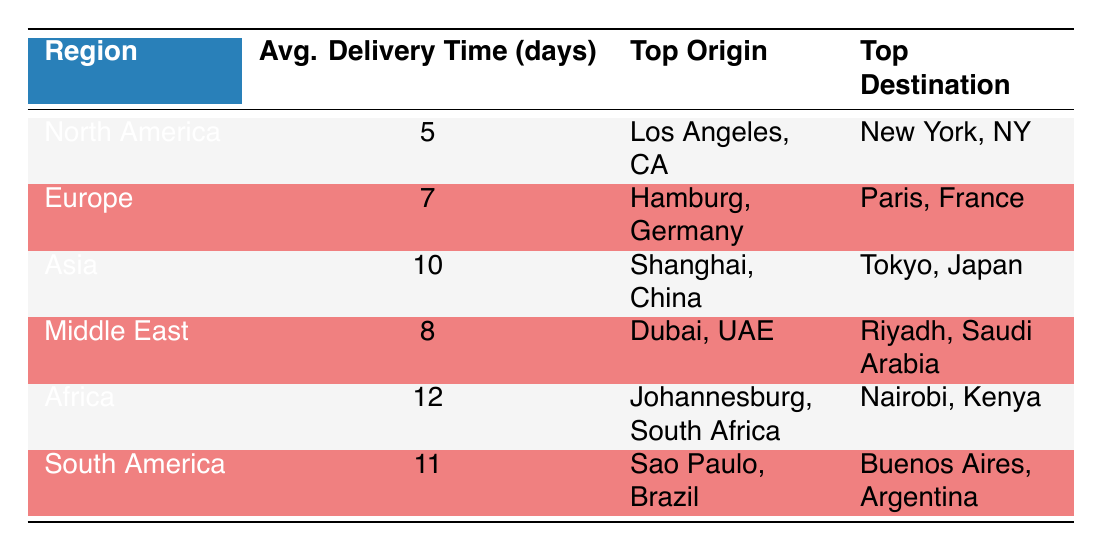What is the average delivery time for goods in North America? The table lists the average delivery time for North America as 5 days.
Answer: 5 days Which region has the longest average delivery time? According to the table, Africa has the longest average delivery time at 12 days.
Answer: Africa What is the top origin for shipments to Europe? The table indicates that the top origin for shipments in Europe is Hamburg, Germany.
Answer: Hamburg, Germany Is the average delivery time in Asia greater than that in Europe? Comparing the average delivery times from the table, Asia's delivery time is 10 days, while Europe's is 7 days, making the statement true.
Answer: Yes What is the difference in average delivery times between South America and the Middle East? The average delivery time for South America is 11 days, and for the Middle East, it is 8 days. The difference is 11 - 8 = 3 days.
Answer: 3 days Which region's top destination is Riyadh, Saudi Arabia? From the table, the Middle East is listed as the region with Riyadh, Saudi Arabia as the top destination.
Answer: Middle East If we were to average the delivery times of Africa, South America, and Asia, what would that be? The delivery times for Africa, South America, and Asia are 12, 11, and 10 days, respectively. Summing these gives 12 + 11 + 10 = 33 days. Dividing by 3 for the average yields 33 / 3 = 11 days.
Answer: 11 days Are Los Angeles, CA and New York, NY part of the same region? The top origin and destination for North America are Los Angeles, CA and New York, NY respectively. This indicates that they are indeed part of the same region.
Answer: Yes What is the average delivery time for goods coming from Shanghai, China? The table shows that shipments originating from Shanghai, China are associated with an average delivery time of 10 days, as Asia is the related region.
Answer: 10 days 